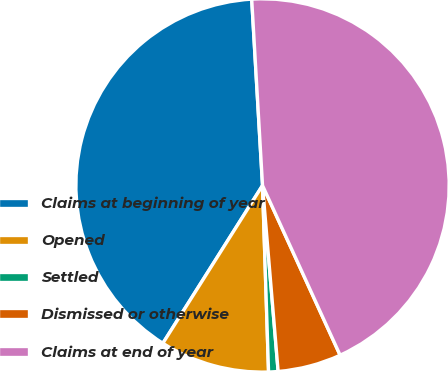Convert chart. <chart><loc_0><loc_0><loc_500><loc_500><pie_chart><fcel>Claims at beginning of year<fcel>Opened<fcel>Settled<fcel>Dismissed or otherwise<fcel>Claims at end of year<nl><fcel>40.11%<fcel>9.48%<fcel>0.82%<fcel>5.49%<fcel>44.1%<nl></chart> 